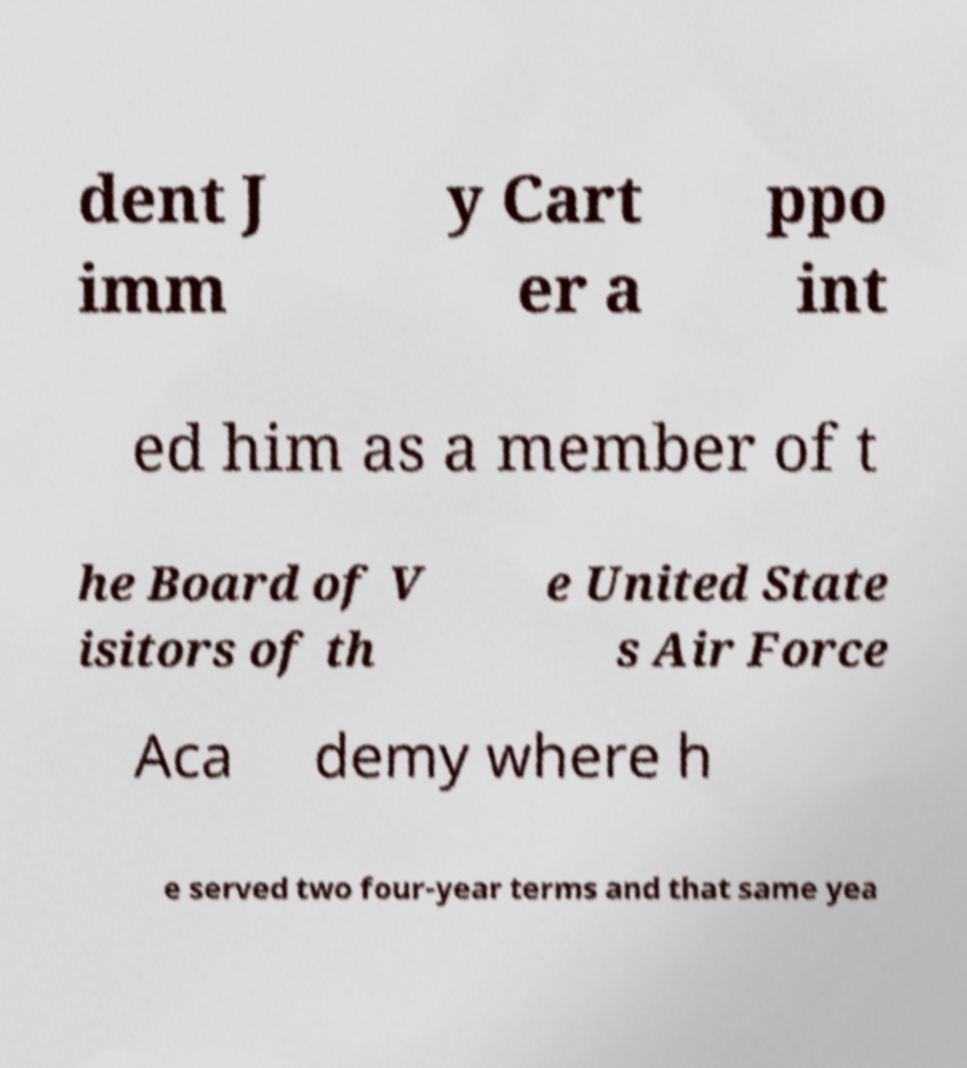For documentation purposes, I need the text within this image transcribed. Could you provide that? dent J imm y Cart er a ppo int ed him as a member of t he Board of V isitors of th e United State s Air Force Aca demy where h e served two four-year terms and that same yea 